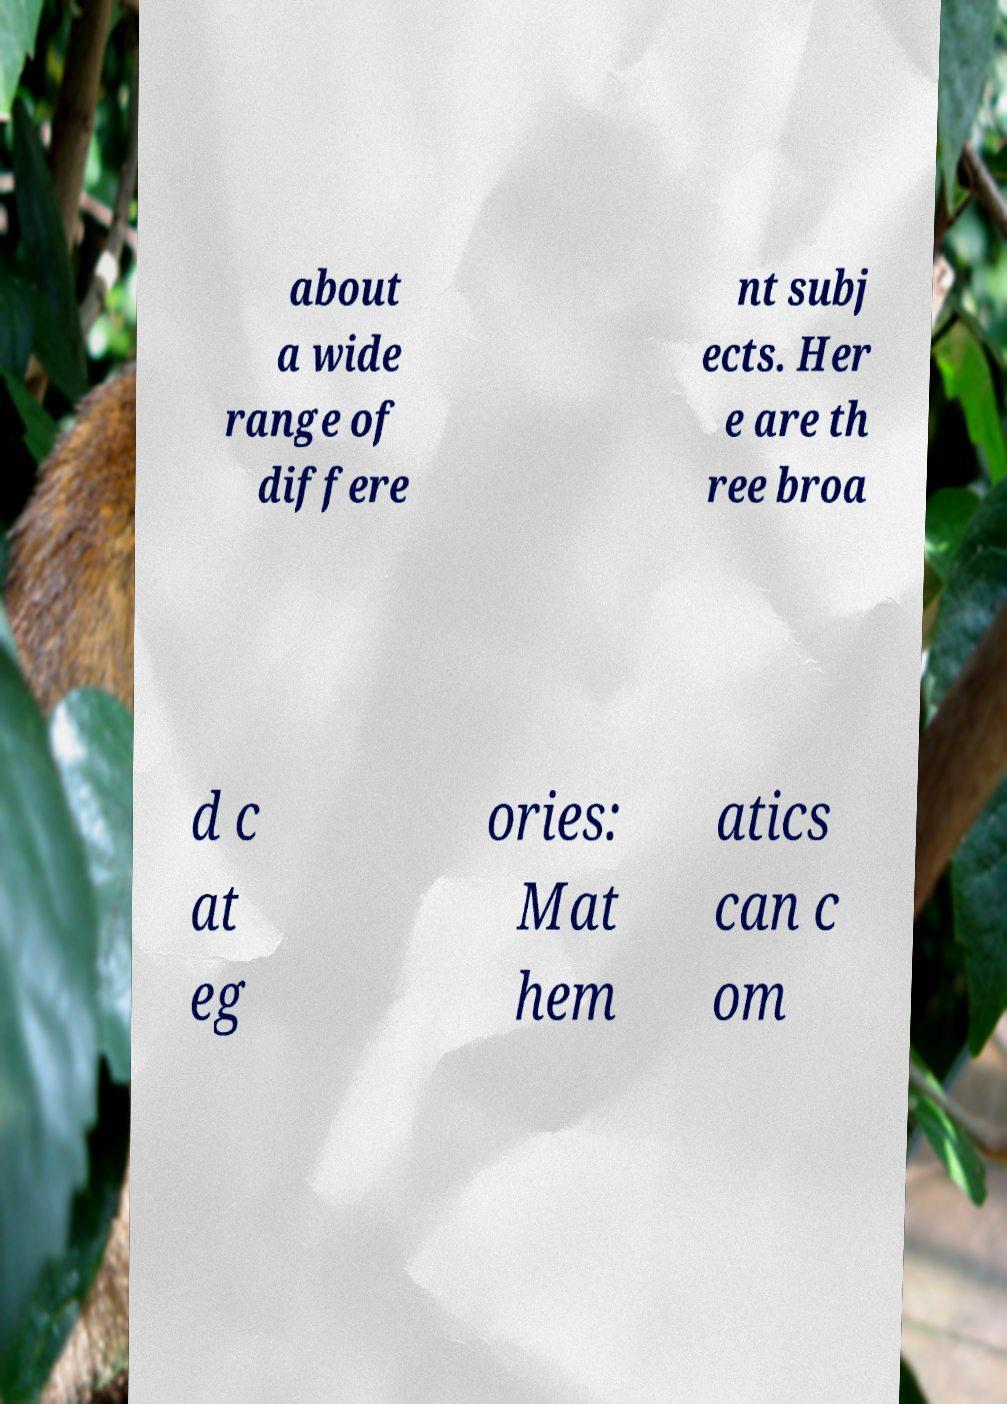Please identify and transcribe the text found in this image. about a wide range of differe nt subj ects. Her e are th ree broa d c at eg ories: Mat hem atics can c om 